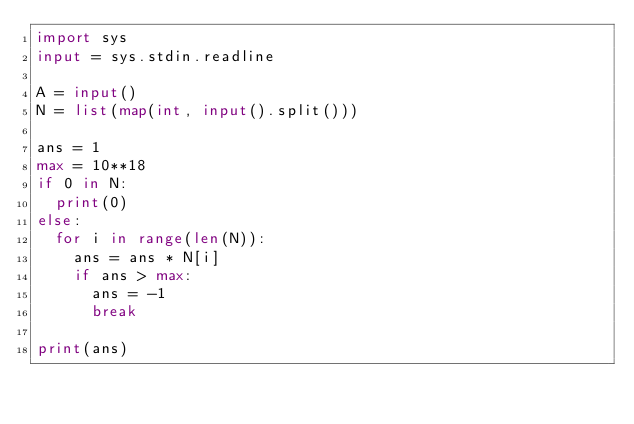<code> <loc_0><loc_0><loc_500><loc_500><_Python_>import sys
input = sys.stdin.readline

A = input()
N = list(map(int, input().split()))

ans = 1
max = 10**18
if 0 in N:
  print(0)
else:
  for i in range(len(N)):
    ans = ans * N[i]
    if ans > max:
      ans = -1
      break

print(ans)</code> 